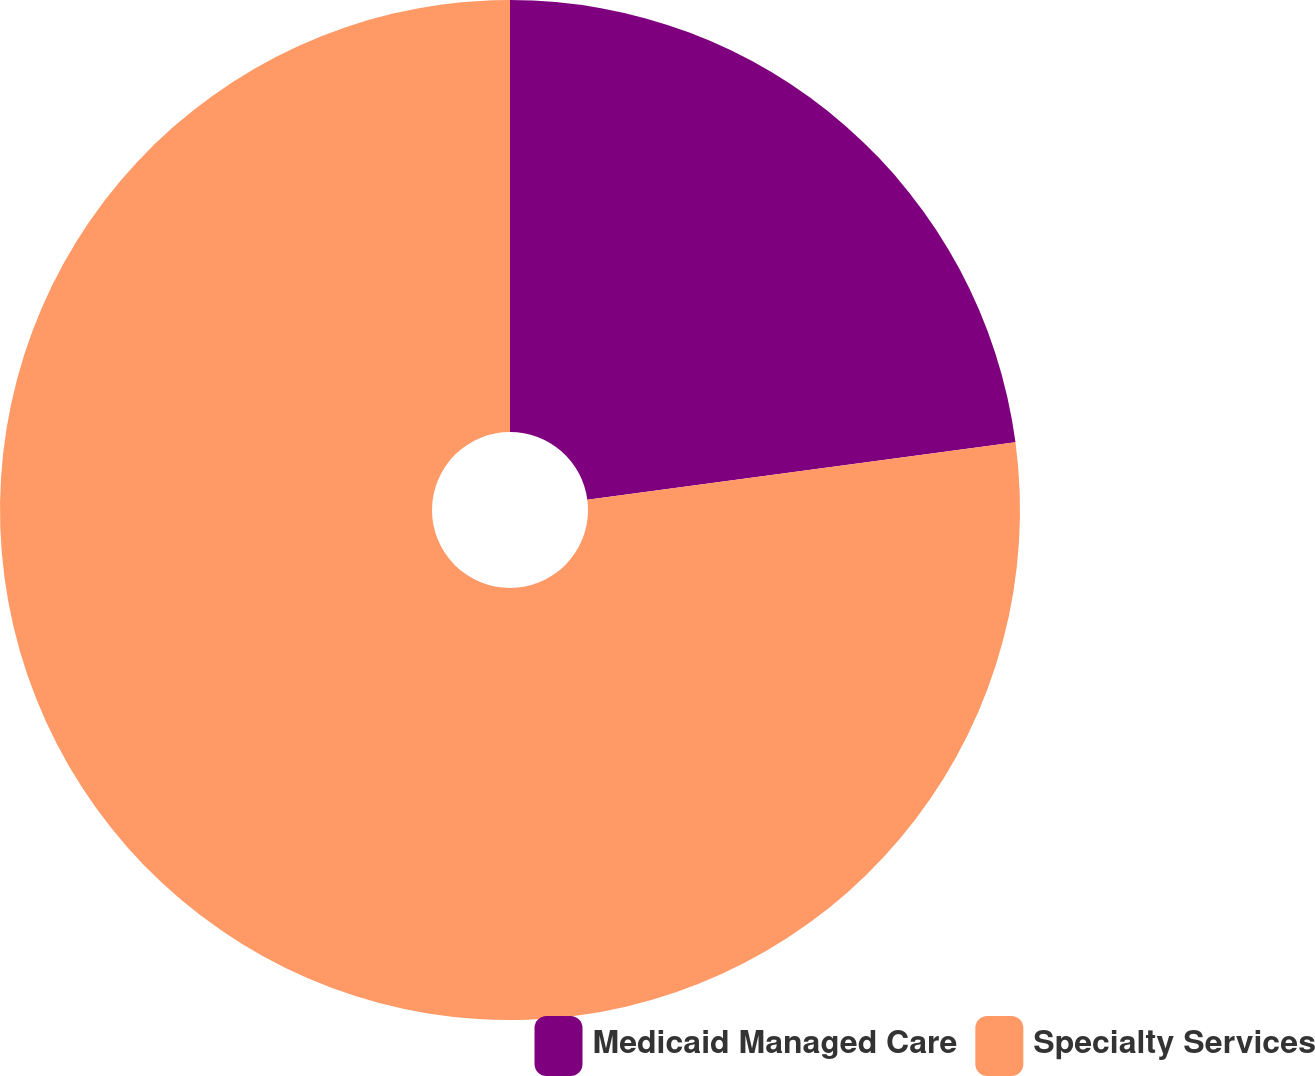Convert chart to OTSL. <chart><loc_0><loc_0><loc_500><loc_500><pie_chart><fcel>Medicaid Managed Care<fcel>Specialty Services<nl><fcel>22.88%<fcel>77.12%<nl></chart> 